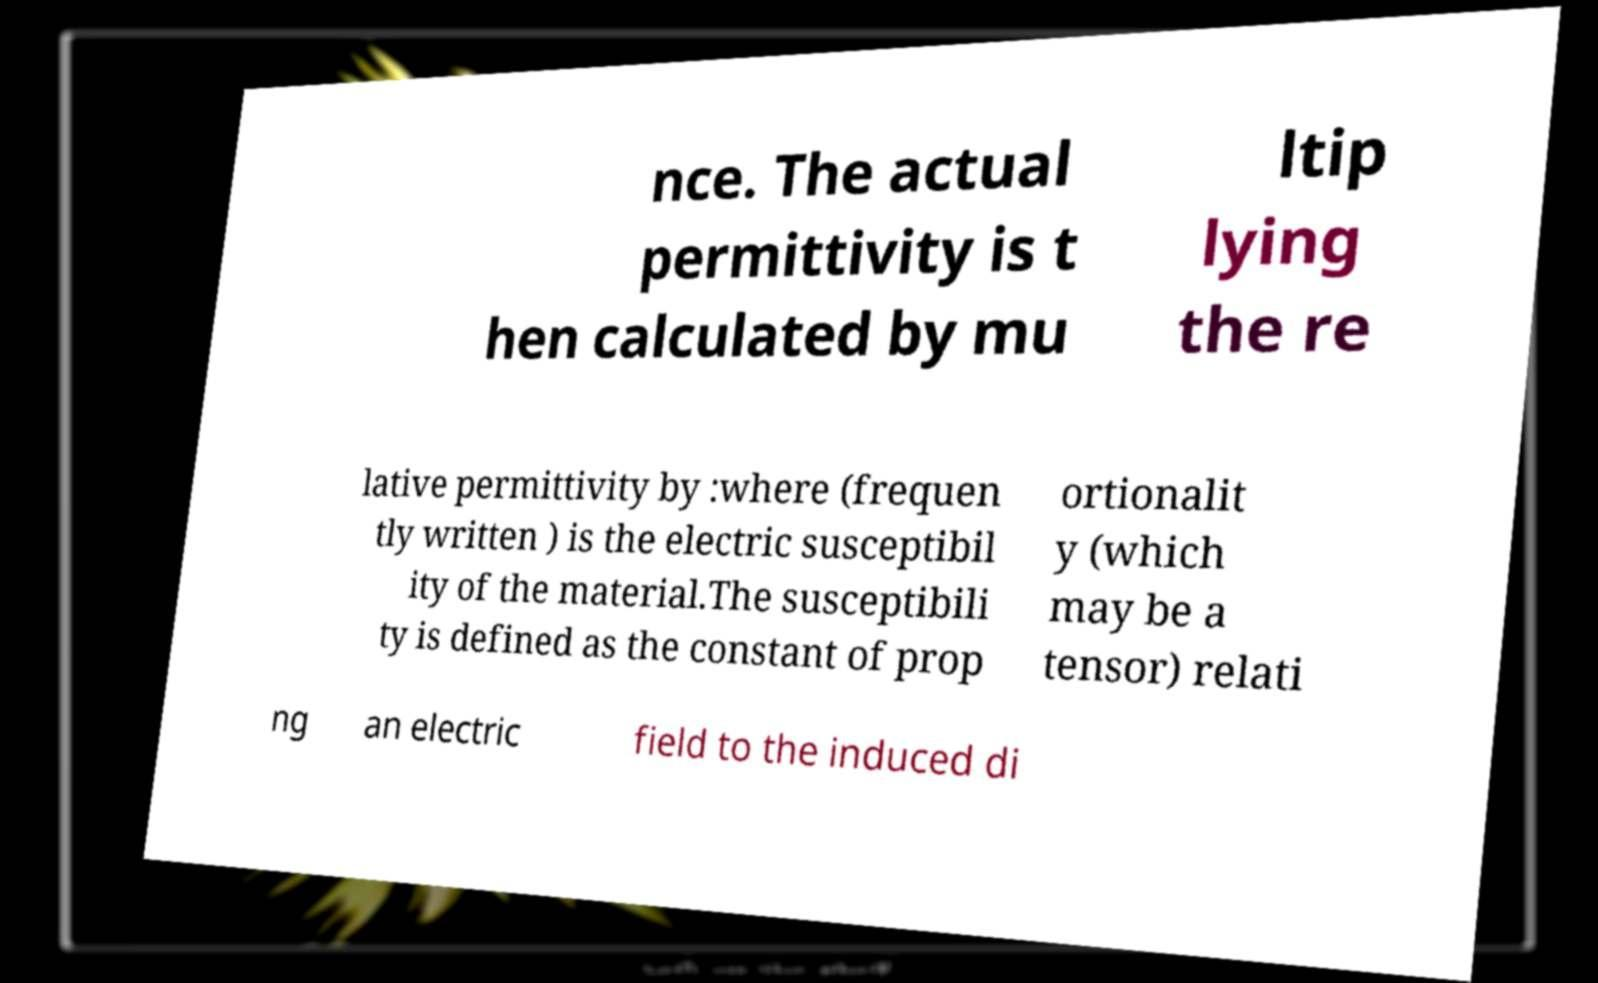Could you extract and type out the text from this image? nce. The actual permittivity is t hen calculated by mu ltip lying the re lative permittivity by :where (frequen tly written ) is the electric susceptibil ity of the material.The susceptibili ty is defined as the constant of prop ortionalit y (which may be a tensor) relati ng an electric field to the induced di 